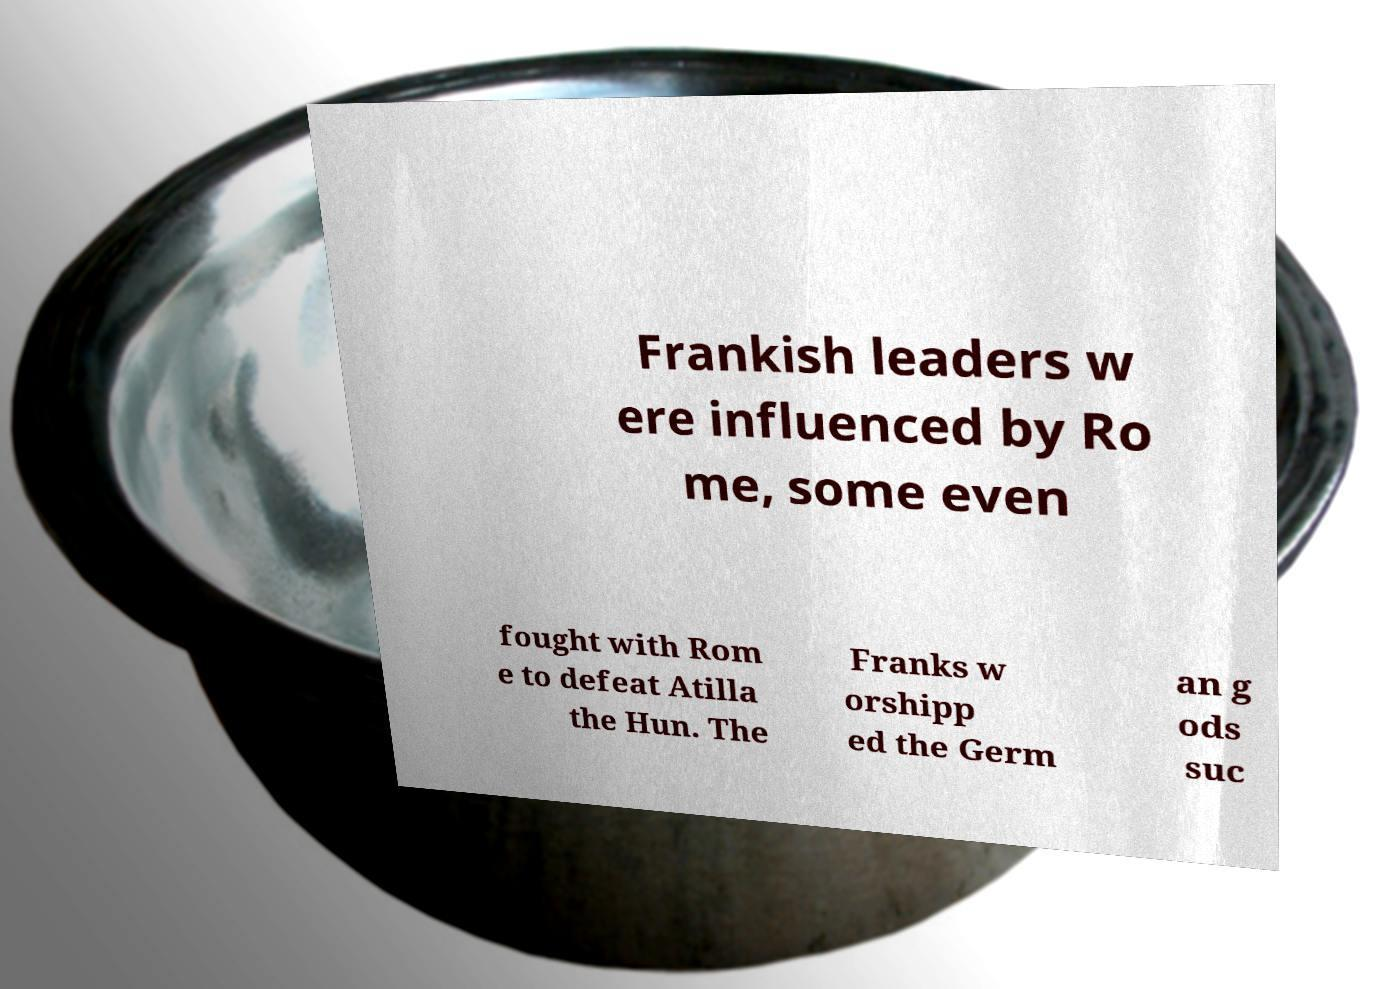Could you extract and type out the text from this image? Frankish leaders w ere influenced by Ro me, some even fought with Rom e to defeat Atilla the Hun. The Franks w orshipp ed the Germ an g ods suc 